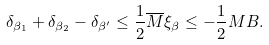<formula> <loc_0><loc_0><loc_500><loc_500>\delta _ { \beta _ { 1 } } + \delta _ { \beta _ { 2 } } - \delta _ { \beta ^ { \prime } } \leq \frac { 1 } { 2 } \overline { M } \xi _ { \beta } \leq - \frac { 1 } { 2 } M B .</formula> 